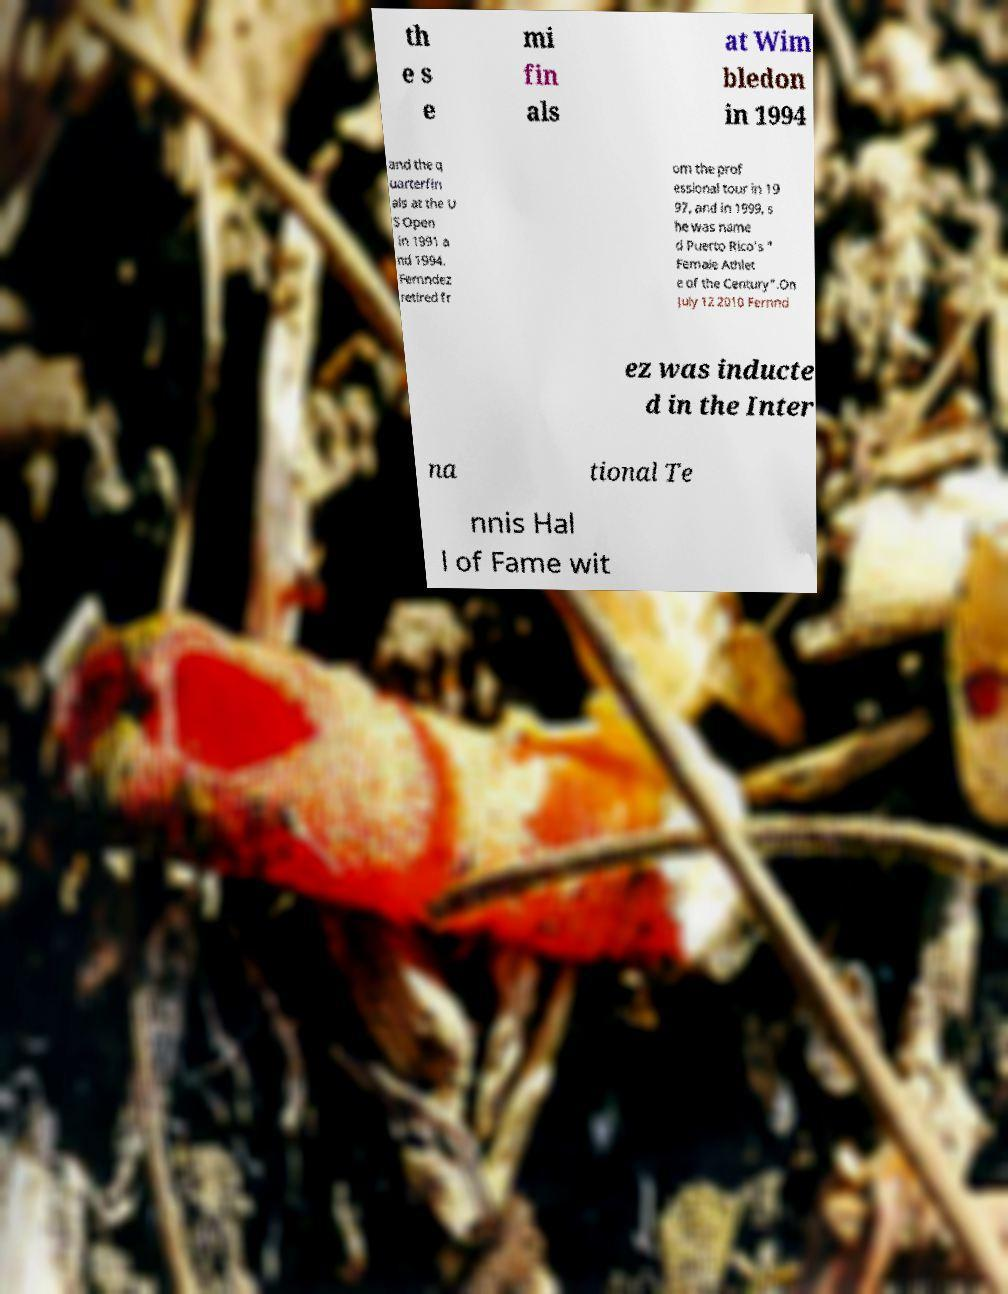I need the written content from this picture converted into text. Can you do that? th e s e mi fin als at Wim bledon in 1994 and the q uarterfin als at the U S Open in 1991 a nd 1994. Fernndez retired fr om the prof essional tour in 19 97, and in 1999, s he was name d Puerto Rico's " Female Athlet e of the Century".On July 12 2010 Fernnd ez was inducte d in the Inter na tional Te nnis Hal l of Fame wit 